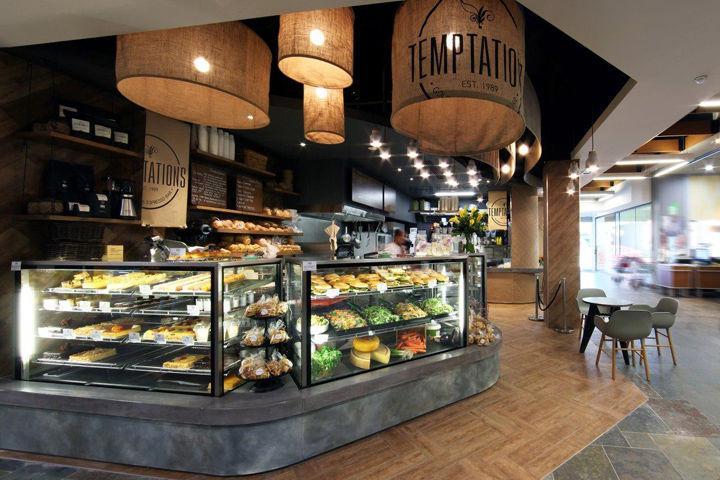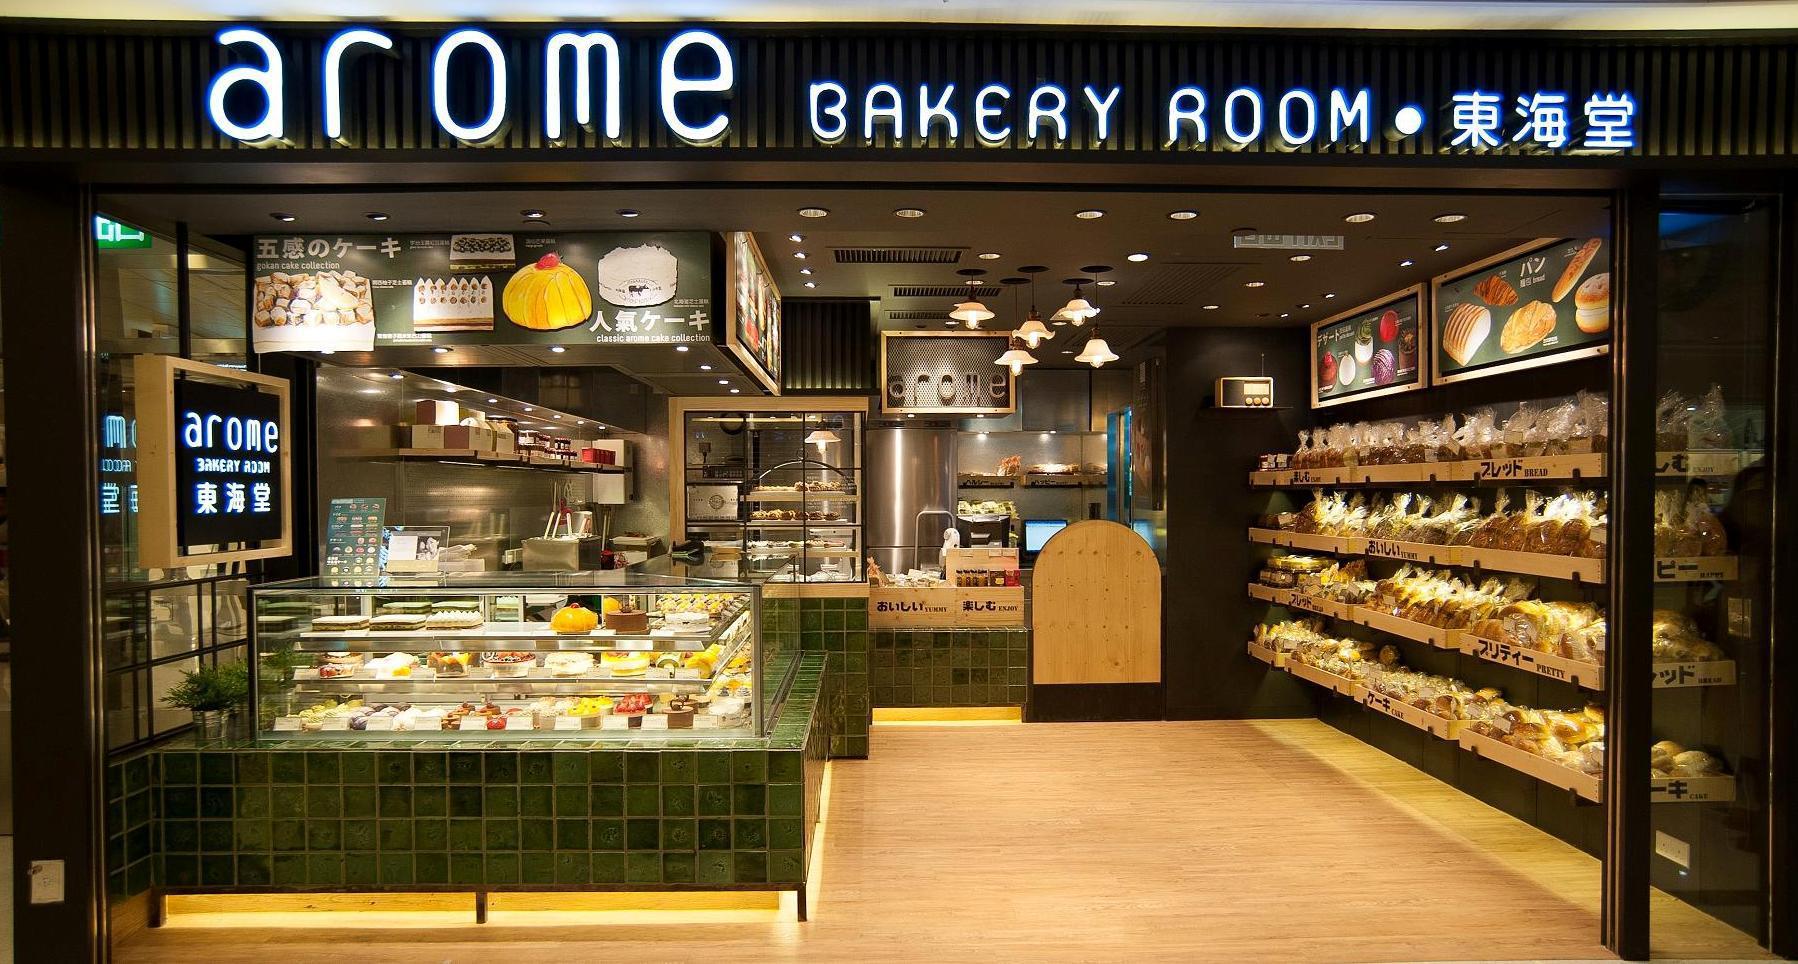The first image is the image on the left, the second image is the image on the right. Given the left and right images, does the statement "There is at least one chair outside in front of a building." hold true? Answer yes or no. No. 